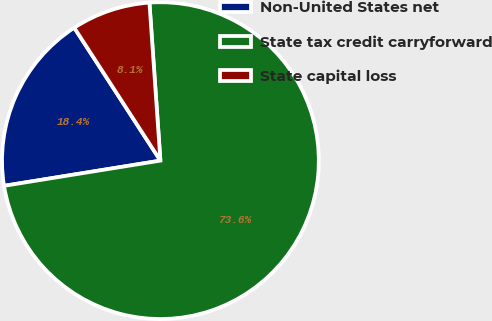<chart> <loc_0><loc_0><loc_500><loc_500><pie_chart><fcel>Non-United States net<fcel>State tax credit carryforward<fcel>State capital loss<nl><fcel>18.39%<fcel>73.56%<fcel>8.05%<nl></chart> 